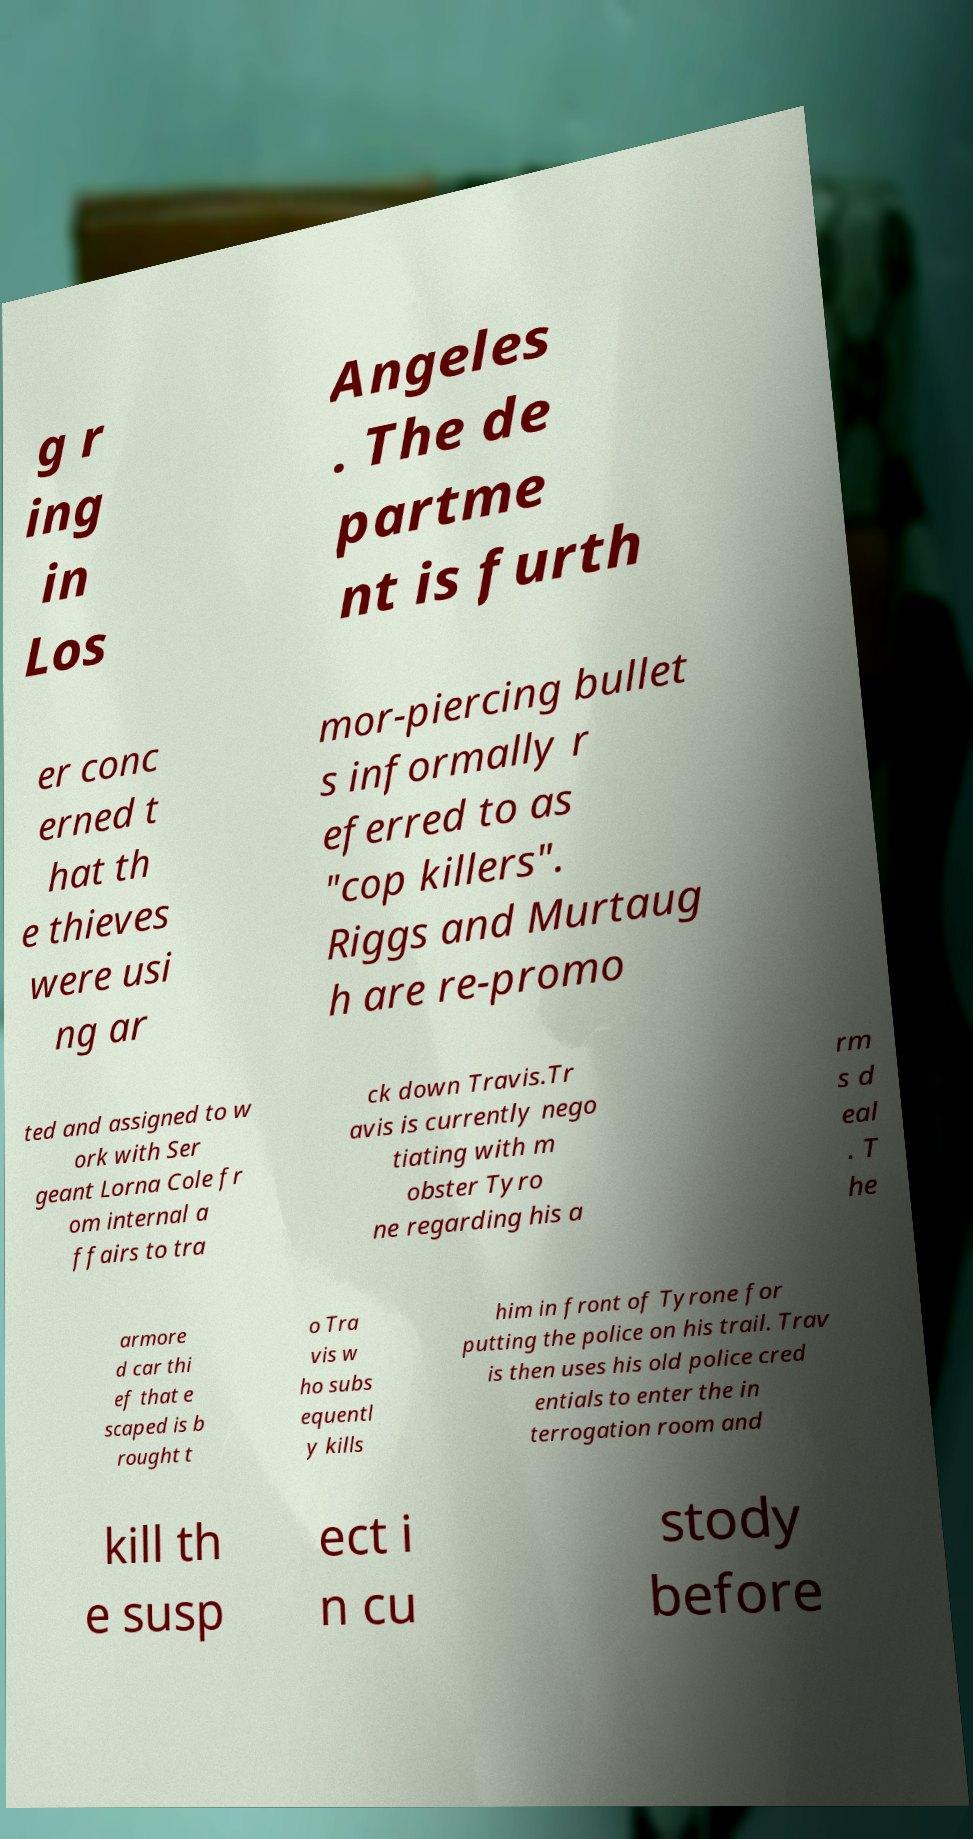For documentation purposes, I need the text within this image transcribed. Could you provide that? g r ing in Los Angeles . The de partme nt is furth er conc erned t hat th e thieves were usi ng ar mor-piercing bullet s informally r eferred to as "cop killers". Riggs and Murtaug h are re-promo ted and assigned to w ork with Ser geant Lorna Cole fr om internal a ffairs to tra ck down Travis.Tr avis is currently nego tiating with m obster Tyro ne regarding his a rm s d eal . T he armore d car thi ef that e scaped is b rought t o Tra vis w ho subs equentl y kills him in front of Tyrone for putting the police on his trail. Trav is then uses his old police cred entials to enter the in terrogation room and kill th e susp ect i n cu stody before 